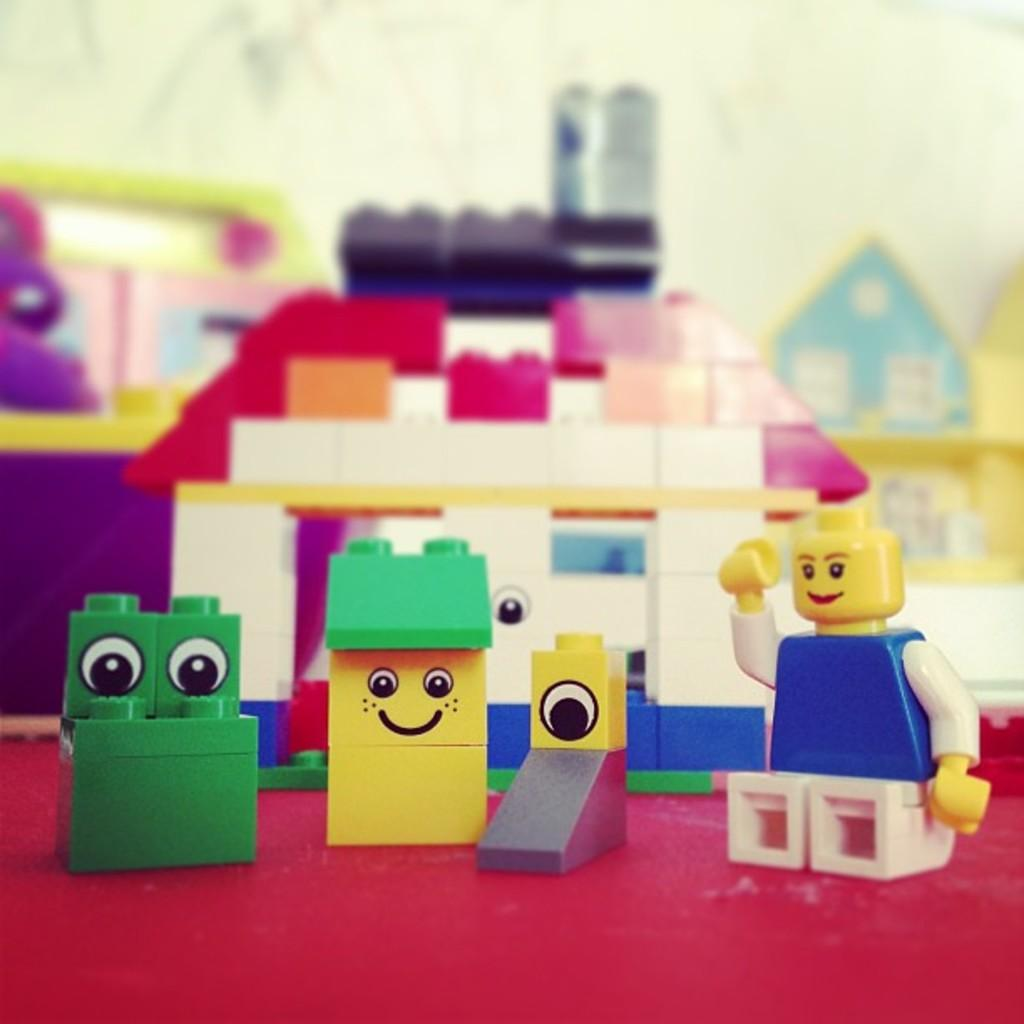What objects are present in the image? There are toys in the image. Can you describe the appearance of the toys? The toys are in different colors. What is the color of the surface on which the toys are placed? The toys are on a red color surface. How would you describe the background of the image? The background of the image is blurred. What type of cloud can be seen in the image? There are no clouds present in the image; it features toys on a red surface with a blurred background. 